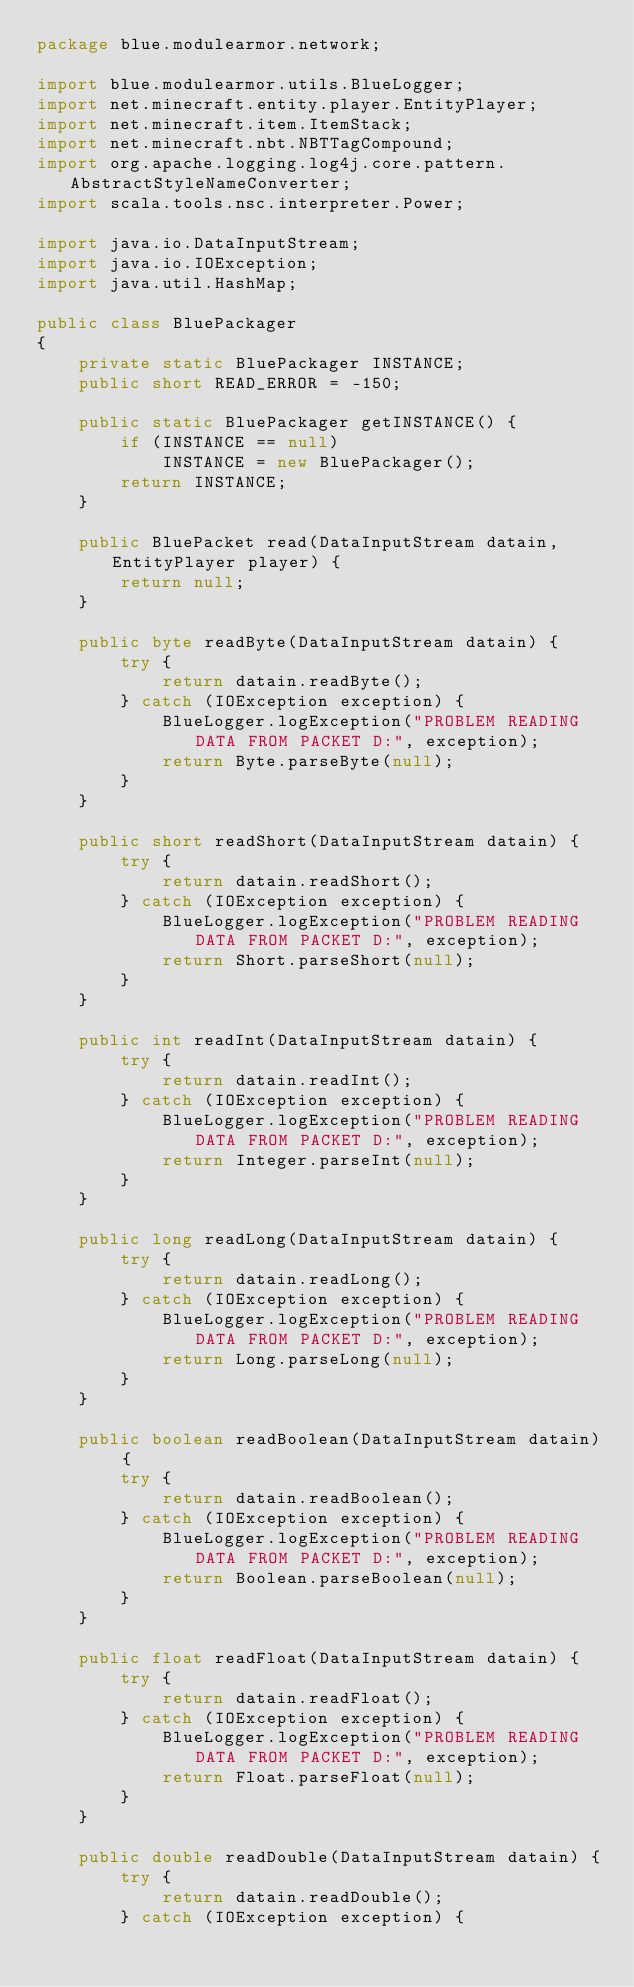<code> <loc_0><loc_0><loc_500><loc_500><_Java_>package blue.modulearmor.network;

import blue.modulearmor.utils.BlueLogger;
import net.minecraft.entity.player.EntityPlayer;
import net.minecraft.item.ItemStack;
import net.minecraft.nbt.NBTTagCompound;
import org.apache.logging.log4j.core.pattern.AbstractStyleNameConverter;
import scala.tools.nsc.interpreter.Power;

import java.io.DataInputStream;
import java.io.IOException;
import java.util.HashMap;

public class BluePackager
{
    private static BluePackager INSTANCE;
    public short READ_ERROR = -150;

    public static BluePackager getINSTANCE() {
        if (INSTANCE == null)
            INSTANCE = new BluePackager();
        return INSTANCE;
    }

    public BluePacket read(DataInputStream datain, EntityPlayer player) {
        return null;
    }

    public byte readByte(DataInputStream datain) {
        try {
            return datain.readByte();
        } catch (IOException exception) {
            BlueLogger.logException("PROBLEM READING DATA FROM PACKET D:", exception);
            return Byte.parseByte(null);
        }
    }

    public short readShort(DataInputStream datain) {
        try {
            return datain.readShort();
        } catch (IOException exception) {
            BlueLogger.logException("PROBLEM READING DATA FROM PACKET D:", exception);
            return Short.parseShort(null);
        }
    }

    public int readInt(DataInputStream datain) {
        try {
            return datain.readInt();
        } catch (IOException exception) {
            BlueLogger.logException("PROBLEM READING DATA FROM PACKET D:", exception);
            return Integer.parseInt(null);
        }
    }

    public long readLong(DataInputStream datain) {
        try {
            return datain.readLong();
        } catch (IOException exception) {
            BlueLogger.logException("PROBLEM READING DATA FROM PACKET D:", exception);
            return Long.parseLong(null);
        }
    }

    public boolean readBoolean(DataInputStream datain) {
        try {
            return datain.readBoolean();
        } catch (IOException exception) {
            BlueLogger.logException("PROBLEM READING DATA FROM PACKET D:", exception);
            return Boolean.parseBoolean(null);
        }
    }

    public float readFloat(DataInputStream datain) {
        try {
            return datain.readFloat();
        } catch (IOException exception) {
            BlueLogger.logException("PROBLEM READING DATA FROM PACKET D:", exception);
            return Float.parseFloat(null);
        }
    }

    public double readDouble(DataInputStream datain) {
        try {
            return datain.readDouble();
        } catch (IOException exception) {</code> 